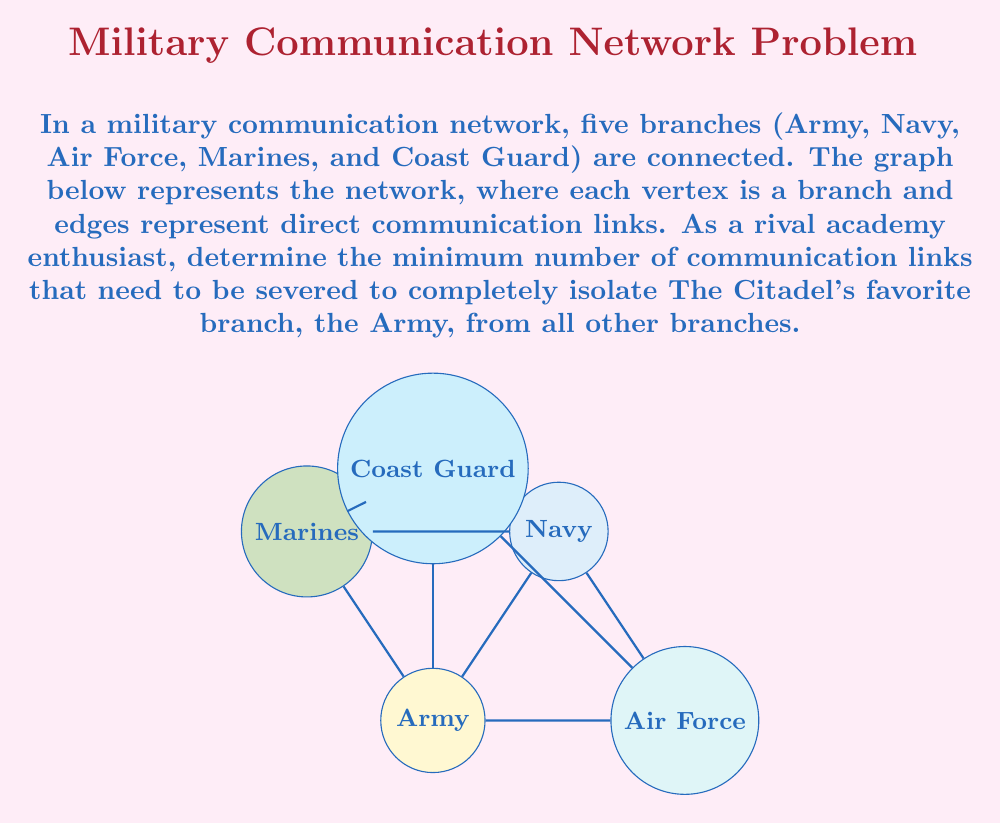Can you solve this math problem? To solve this problem, we need to analyze the connectivity of the Army node in the given graph:

1) First, identify all edges connected to the Army node:
   - Army -- Navy
   - Army -- Marines
   - Army -- Coast Guard
   - Army -- Air Force

2) The minimum number of edges that need to be removed to isolate a node is equal to its degree (number of edges connected to it).

3) Count the degree of the Army node:
   $\text{degree}(\text{Army}) = 4$

4) Therefore, we need to remove all 4 edges connected to the Army node to completely isolate it from all other branches.

5) This solution ensures that no communication path exists between the Army and any other branch, effectively isolating it in the network.

Note: This approach is equivalent to finding the vertex connectivity of the Army node, which is the minimum number of vertices that need to be removed to disconnect the node from the graph. In this case, it's equal to the degree of the node due to the graph's structure.
Answer: 4 